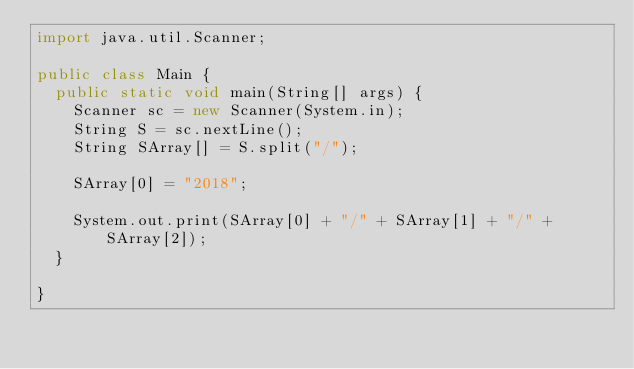Convert code to text. <code><loc_0><loc_0><loc_500><loc_500><_Java_>import java.util.Scanner;

public class Main {
	public static void main(String[] args) {
		Scanner sc = new Scanner(System.in);
		String S = sc.nextLine();
		String SArray[] = S.split("/");

		SArray[0] = "2018";

		System.out.print(SArray[0] + "/" + SArray[1] + "/" + SArray[2]);
	}

}</code> 